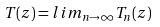<formula> <loc_0><loc_0><loc_500><loc_500>T ( z ) = l i m _ { n \rightarrow \infty } T _ { n } ( z )</formula> 